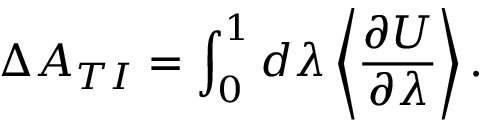Convert formula to latex. <formula><loc_0><loc_0><loc_500><loc_500>\Delta A _ { T I } = \int _ { 0 } ^ { 1 } d \lambda \left \langle \frac { \partial U } { \partial \lambda } \right \rangle .</formula> 